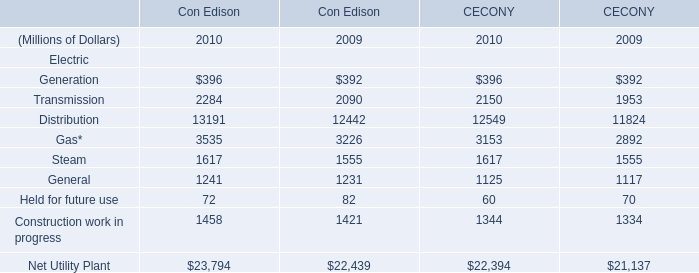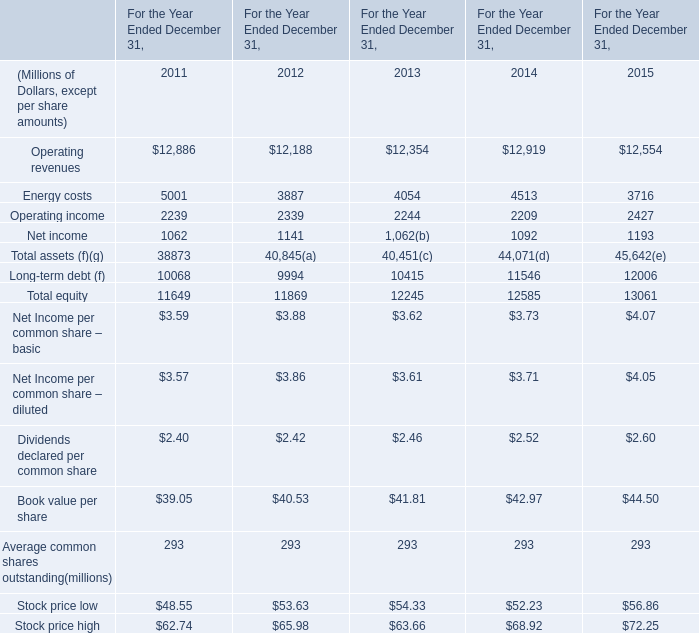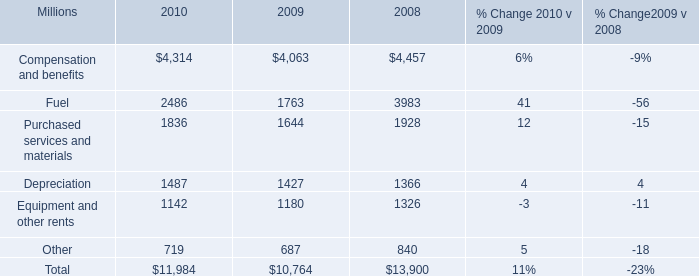What is the average amount of Purchased services and materials of 2010, and Energy costs of For the Year Ended December 31, 2011 ? 
Computations: ((1836.0 + 5001.0) / 2)
Answer: 3418.5. 